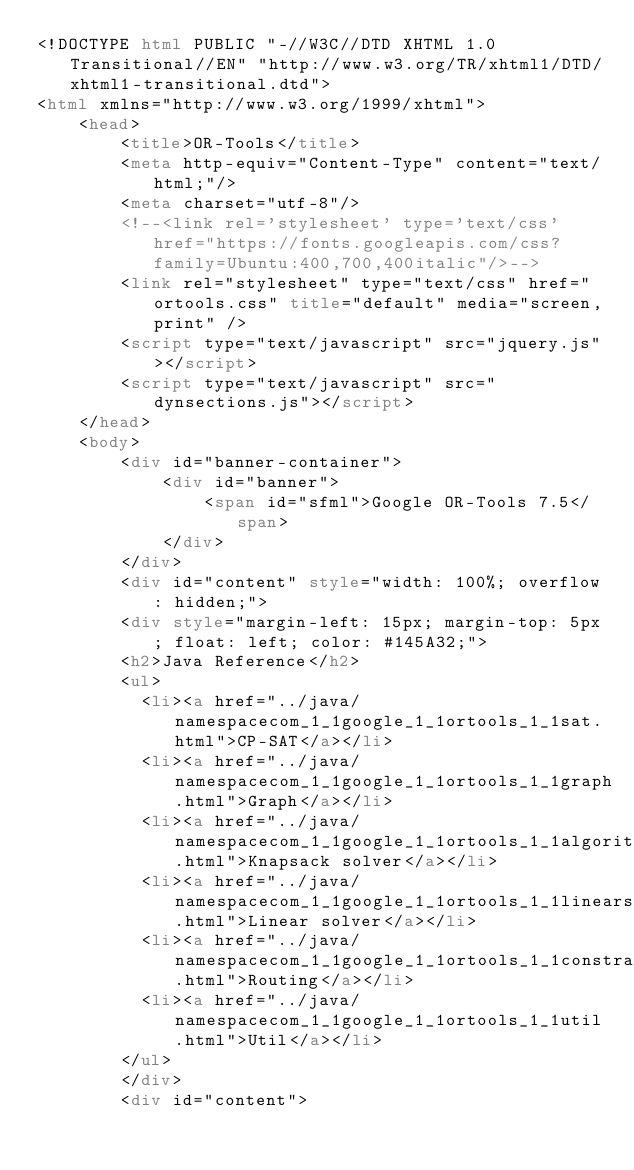Convert code to text. <code><loc_0><loc_0><loc_500><loc_500><_HTML_><!DOCTYPE html PUBLIC "-//W3C//DTD XHTML 1.0 Transitional//EN" "http://www.w3.org/TR/xhtml1/DTD/xhtml1-transitional.dtd">
<html xmlns="http://www.w3.org/1999/xhtml">
    <head>
        <title>OR-Tools</title>
        <meta http-equiv="Content-Type" content="text/html;"/>
        <meta charset="utf-8"/>
        <!--<link rel='stylesheet' type='text/css' href="https://fonts.googleapis.com/css?family=Ubuntu:400,700,400italic"/>-->
        <link rel="stylesheet" type="text/css" href="ortools.css" title="default" media="screen,print" />
        <script type="text/javascript" src="jquery.js"></script>
        <script type="text/javascript" src="dynsections.js"></script>
    </head>
    <body>
        <div id="banner-container">
            <div id="banner">
                <span id="sfml">Google OR-Tools 7.5</span>
            </div>
        </div>
        <div id="content" style="width: 100%; overflow: hidden;">
        <div style="margin-left: 15px; margin-top: 5px; float: left; color: #145A32;">
        <h2>Java Reference</h2>
        <ul>
          <li><a href="../java/namespacecom_1_1google_1_1ortools_1_1sat.html">CP-SAT</a></li>
          <li><a href="../java/namespacecom_1_1google_1_1ortools_1_1graph.html">Graph</a></li>
          <li><a href="../java/namespacecom_1_1google_1_1ortools_1_1algorithms.html">Knapsack solver</a></li>
          <li><a href="../java/namespacecom_1_1google_1_1ortools_1_1linearsolver.html">Linear solver</a></li>
          <li><a href="../java/namespacecom_1_1google_1_1ortools_1_1constraintsolver.html">Routing</a></li>
          <li><a href="../java/namespacecom_1_1google_1_1ortools_1_1util.html">Util</a></li>
        </ul>
        </div>
        <div id="content"></code> 